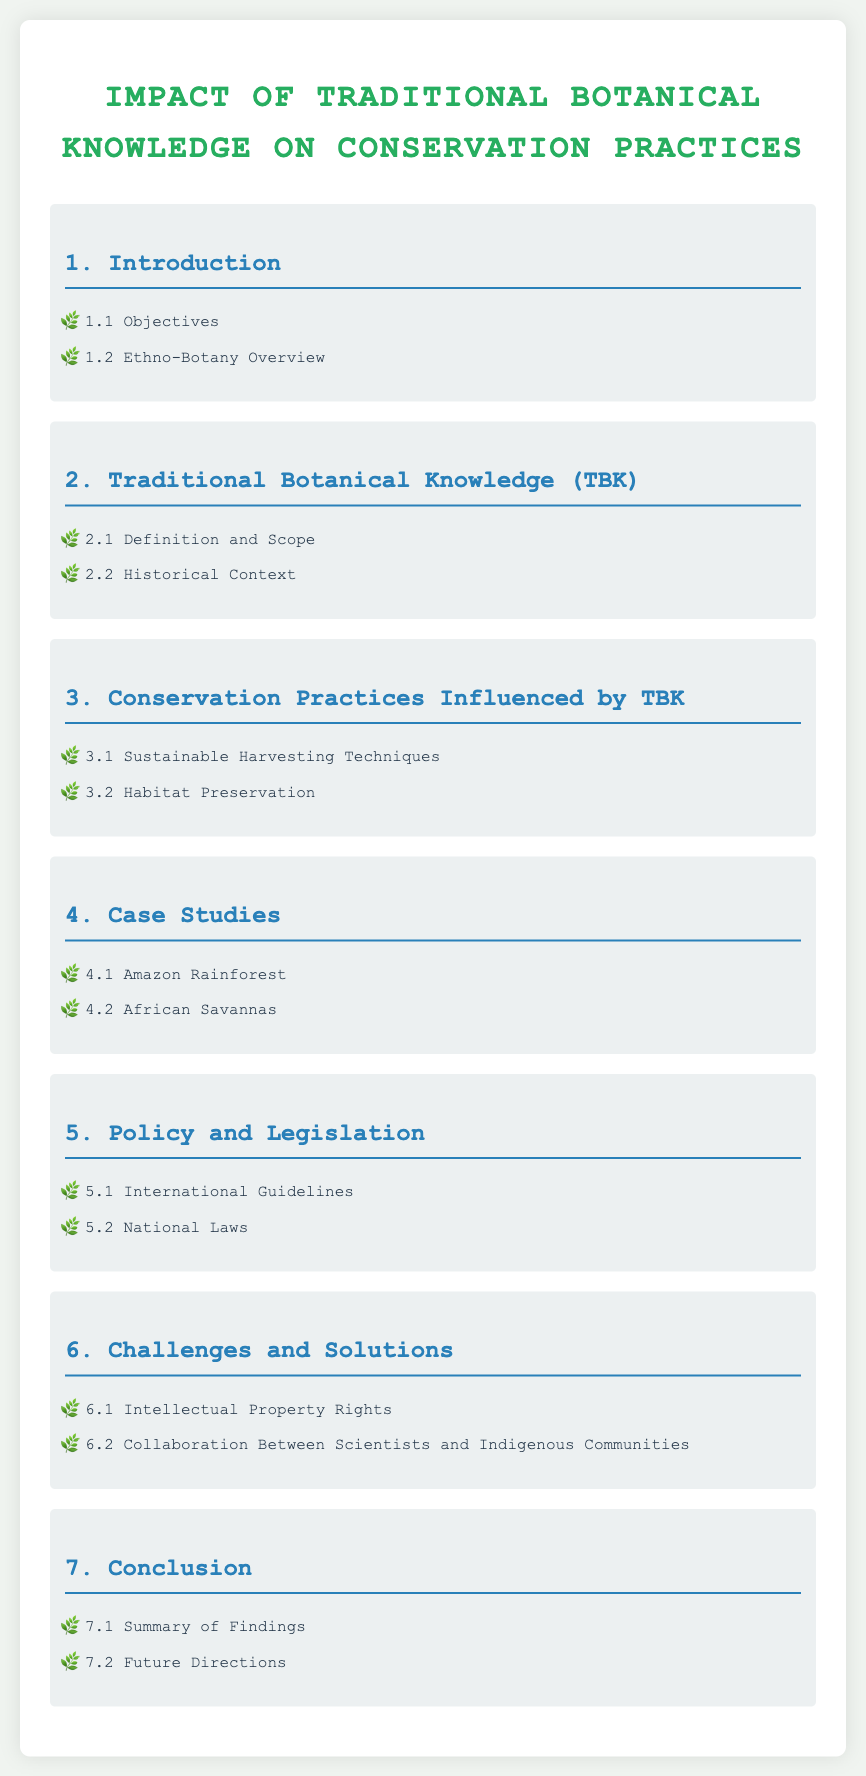What is the main title of the document? The main title is stated clearly at the top of the document, which indicates the primary focus of the content.
Answer: Impact of Traditional Botanical Knowledge on Conservation Practices How many sections are in the document? The number of sections can be counted from the main content in the Table of Contents.
Answer: 7 What is discussed in section 3? Section 3 outlines specific practices that are influenced by Traditional Botanical Knowledge, which is crucial for understanding its impact on conservation.
Answer: Conservation Practices Influenced by TBK What are two case studies mentioned in the document? The document specifies particular geographical areas in the case studies section that exemplify the effects of botanical knowledge.
Answer: Amazon Rainforest, African Savannas What topic is covered under section 6.2? Section 6.2 focuses on a specific relationship that is important for addressing challenges related to botanical knowledge.
Answer: Collaboration Between Scientists and Indigenous Communities What is the focus of section 5.1? Section 5.1 addresses specific guidelines that govern international approaches to conservation, providing a legal frame for action.
Answer: International Guidelines Which section includes the objectives of the study? The objectives of the study are likely stated at the beginning and are critical for understanding the purpose of the content.
Answer: 1.1 Objectives 